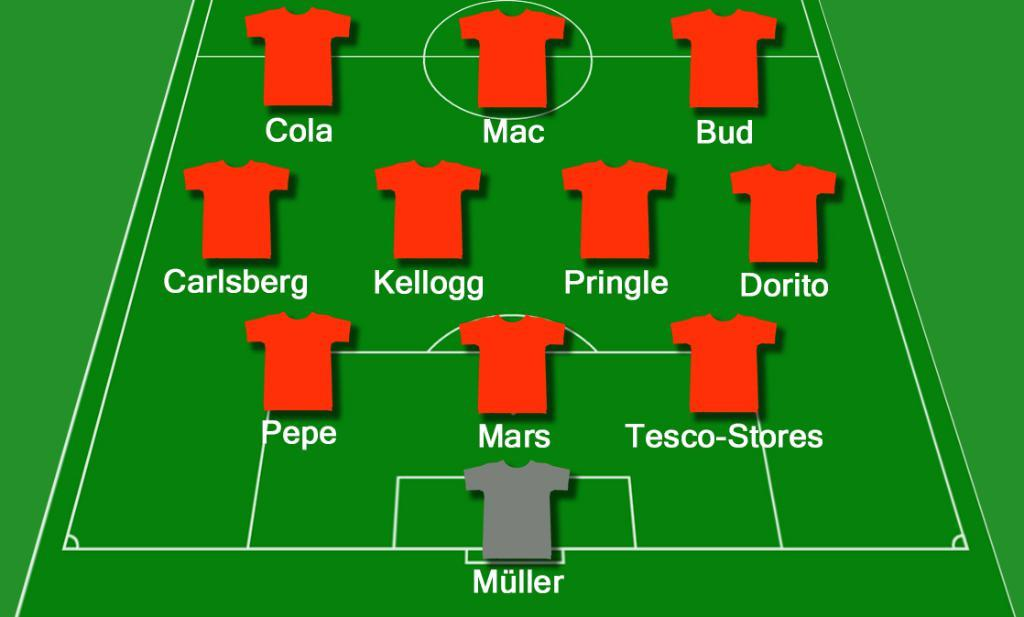<image>
Relay a brief, clear account of the picture shown. a player lineup that has the word mac on it 